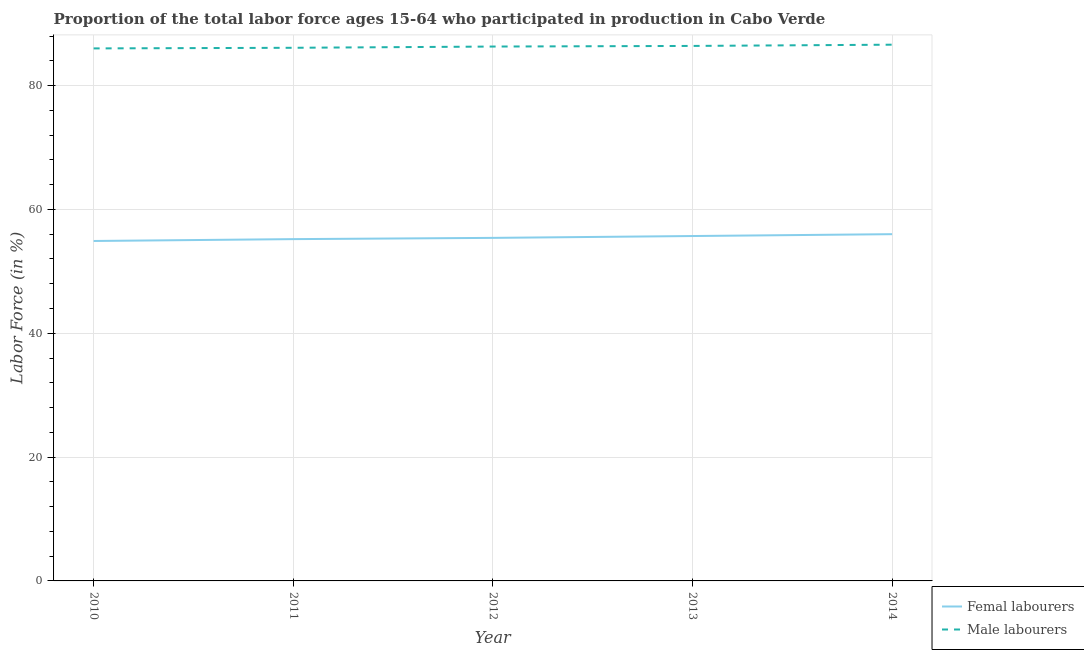Is the number of lines equal to the number of legend labels?
Give a very brief answer. Yes. What is the percentage of male labour force in 2013?
Give a very brief answer. 86.4. In which year was the percentage of female labor force maximum?
Give a very brief answer. 2014. What is the total percentage of male labour force in the graph?
Your response must be concise. 431.4. What is the difference between the percentage of female labor force in 2012 and that in 2013?
Provide a short and direct response. -0.3. What is the difference between the percentage of female labor force in 2013 and the percentage of male labour force in 2011?
Keep it short and to the point. -30.4. What is the average percentage of male labour force per year?
Make the answer very short. 86.28. In the year 2012, what is the difference between the percentage of male labour force and percentage of female labor force?
Keep it short and to the point. 30.9. In how many years, is the percentage of male labour force greater than 32 %?
Ensure brevity in your answer.  5. What is the ratio of the percentage of female labor force in 2012 to that in 2013?
Make the answer very short. 0.99. Is the difference between the percentage of male labour force in 2012 and 2013 greater than the difference between the percentage of female labor force in 2012 and 2013?
Provide a short and direct response. Yes. What is the difference between the highest and the second highest percentage of female labor force?
Give a very brief answer. 0.3. What is the difference between the highest and the lowest percentage of female labor force?
Your answer should be compact. 1.1. Is the sum of the percentage of female labor force in 2010 and 2013 greater than the maximum percentage of male labour force across all years?
Make the answer very short. Yes. Does the percentage of female labor force monotonically increase over the years?
Offer a terse response. Yes. How many years are there in the graph?
Your answer should be very brief. 5. What is the difference between two consecutive major ticks on the Y-axis?
Your answer should be very brief. 20. How many legend labels are there?
Keep it short and to the point. 2. What is the title of the graph?
Offer a very short reply. Proportion of the total labor force ages 15-64 who participated in production in Cabo Verde. Does "Secondary education" appear as one of the legend labels in the graph?
Make the answer very short. No. What is the label or title of the X-axis?
Ensure brevity in your answer.  Year. What is the label or title of the Y-axis?
Offer a very short reply. Labor Force (in %). What is the Labor Force (in %) in Femal labourers in 2010?
Your answer should be compact. 54.9. What is the Labor Force (in %) of Femal labourers in 2011?
Your response must be concise. 55.2. What is the Labor Force (in %) in Male labourers in 2011?
Your answer should be very brief. 86.1. What is the Labor Force (in %) in Femal labourers in 2012?
Give a very brief answer. 55.4. What is the Labor Force (in %) in Male labourers in 2012?
Provide a short and direct response. 86.3. What is the Labor Force (in %) of Femal labourers in 2013?
Make the answer very short. 55.7. What is the Labor Force (in %) of Male labourers in 2013?
Offer a very short reply. 86.4. What is the Labor Force (in %) in Male labourers in 2014?
Your response must be concise. 86.6. Across all years, what is the maximum Labor Force (in %) in Femal labourers?
Give a very brief answer. 56. Across all years, what is the maximum Labor Force (in %) of Male labourers?
Offer a terse response. 86.6. Across all years, what is the minimum Labor Force (in %) in Femal labourers?
Give a very brief answer. 54.9. What is the total Labor Force (in %) in Femal labourers in the graph?
Keep it short and to the point. 277.2. What is the total Labor Force (in %) in Male labourers in the graph?
Provide a short and direct response. 431.4. What is the difference between the Labor Force (in %) in Femal labourers in 2010 and that in 2014?
Make the answer very short. -1.1. What is the difference between the Labor Force (in %) of Male labourers in 2010 and that in 2014?
Your response must be concise. -0.6. What is the difference between the Labor Force (in %) in Femal labourers in 2011 and that in 2012?
Your answer should be very brief. -0.2. What is the difference between the Labor Force (in %) of Male labourers in 2011 and that in 2012?
Offer a very short reply. -0.2. What is the difference between the Labor Force (in %) of Male labourers in 2011 and that in 2013?
Keep it short and to the point. -0.3. What is the difference between the Labor Force (in %) in Male labourers in 2011 and that in 2014?
Provide a succinct answer. -0.5. What is the difference between the Labor Force (in %) in Femal labourers in 2012 and that in 2013?
Your response must be concise. -0.3. What is the difference between the Labor Force (in %) in Male labourers in 2012 and that in 2013?
Your answer should be compact. -0.1. What is the difference between the Labor Force (in %) in Femal labourers in 2012 and that in 2014?
Ensure brevity in your answer.  -0.6. What is the difference between the Labor Force (in %) in Femal labourers in 2013 and that in 2014?
Give a very brief answer. -0.3. What is the difference between the Labor Force (in %) of Femal labourers in 2010 and the Labor Force (in %) of Male labourers in 2011?
Provide a short and direct response. -31.2. What is the difference between the Labor Force (in %) of Femal labourers in 2010 and the Labor Force (in %) of Male labourers in 2012?
Give a very brief answer. -31.4. What is the difference between the Labor Force (in %) of Femal labourers in 2010 and the Labor Force (in %) of Male labourers in 2013?
Offer a very short reply. -31.5. What is the difference between the Labor Force (in %) of Femal labourers in 2010 and the Labor Force (in %) of Male labourers in 2014?
Your response must be concise. -31.7. What is the difference between the Labor Force (in %) in Femal labourers in 2011 and the Labor Force (in %) in Male labourers in 2012?
Your answer should be compact. -31.1. What is the difference between the Labor Force (in %) in Femal labourers in 2011 and the Labor Force (in %) in Male labourers in 2013?
Provide a short and direct response. -31.2. What is the difference between the Labor Force (in %) of Femal labourers in 2011 and the Labor Force (in %) of Male labourers in 2014?
Your response must be concise. -31.4. What is the difference between the Labor Force (in %) in Femal labourers in 2012 and the Labor Force (in %) in Male labourers in 2013?
Make the answer very short. -31. What is the difference between the Labor Force (in %) of Femal labourers in 2012 and the Labor Force (in %) of Male labourers in 2014?
Offer a very short reply. -31.2. What is the difference between the Labor Force (in %) in Femal labourers in 2013 and the Labor Force (in %) in Male labourers in 2014?
Provide a succinct answer. -30.9. What is the average Labor Force (in %) of Femal labourers per year?
Provide a short and direct response. 55.44. What is the average Labor Force (in %) in Male labourers per year?
Make the answer very short. 86.28. In the year 2010, what is the difference between the Labor Force (in %) of Femal labourers and Labor Force (in %) of Male labourers?
Give a very brief answer. -31.1. In the year 2011, what is the difference between the Labor Force (in %) of Femal labourers and Labor Force (in %) of Male labourers?
Ensure brevity in your answer.  -30.9. In the year 2012, what is the difference between the Labor Force (in %) in Femal labourers and Labor Force (in %) in Male labourers?
Ensure brevity in your answer.  -30.9. In the year 2013, what is the difference between the Labor Force (in %) in Femal labourers and Labor Force (in %) in Male labourers?
Offer a terse response. -30.7. In the year 2014, what is the difference between the Labor Force (in %) of Femal labourers and Labor Force (in %) of Male labourers?
Provide a short and direct response. -30.6. What is the ratio of the Labor Force (in %) of Femal labourers in 2010 to that in 2011?
Offer a very short reply. 0.99. What is the ratio of the Labor Force (in %) in Male labourers in 2010 to that in 2011?
Ensure brevity in your answer.  1. What is the ratio of the Labor Force (in %) of Femal labourers in 2010 to that in 2012?
Provide a short and direct response. 0.99. What is the ratio of the Labor Force (in %) of Femal labourers in 2010 to that in 2013?
Ensure brevity in your answer.  0.99. What is the ratio of the Labor Force (in %) of Femal labourers in 2010 to that in 2014?
Provide a short and direct response. 0.98. What is the ratio of the Labor Force (in %) of Male labourers in 2010 to that in 2014?
Give a very brief answer. 0.99. What is the ratio of the Labor Force (in %) in Femal labourers in 2011 to that in 2012?
Offer a terse response. 1. What is the ratio of the Labor Force (in %) of Male labourers in 2011 to that in 2012?
Offer a terse response. 1. What is the ratio of the Labor Force (in %) in Femal labourers in 2011 to that in 2013?
Your answer should be very brief. 0.99. What is the ratio of the Labor Force (in %) in Femal labourers in 2011 to that in 2014?
Provide a short and direct response. 0.99. What is the ratio of the Labor Force (in %) of Male labourers in 2011 to that in 2014?
Your answer should be very brief. 0.99. What is the ratio of the Labor Force (in %) in Femal labourers in 2012 to that in 2013?
Your answer should be very brief. 0.99. What is the ratio of the Labor Force (in %) of Femal labourers in 2012 to that in 2014?
Give a very brief answer. 0.99. What is the ratio of the Labor Force (in %) in Male labourers in 2012 to that in 2014?
Provide a short and direct response. 1. What is the difference between the highest and the second highest Labor Force (in %) of Male labourers?
Offer a terse response. 0.2. What is the difference between the highest and the lowest Labor Force (in %) of Male labourers?
Ensure brevity in your answer.  0.6. 